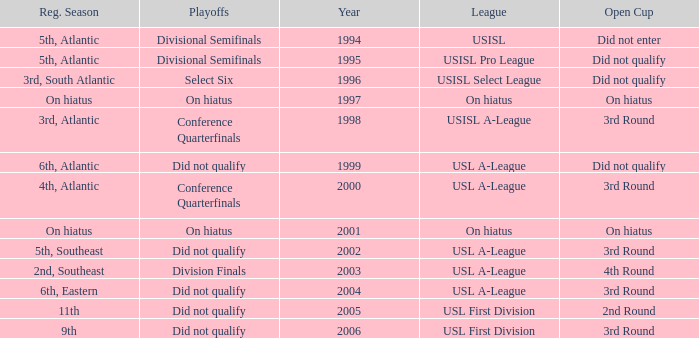What was the earliest year for the USISL Pro League? 1995.0. 